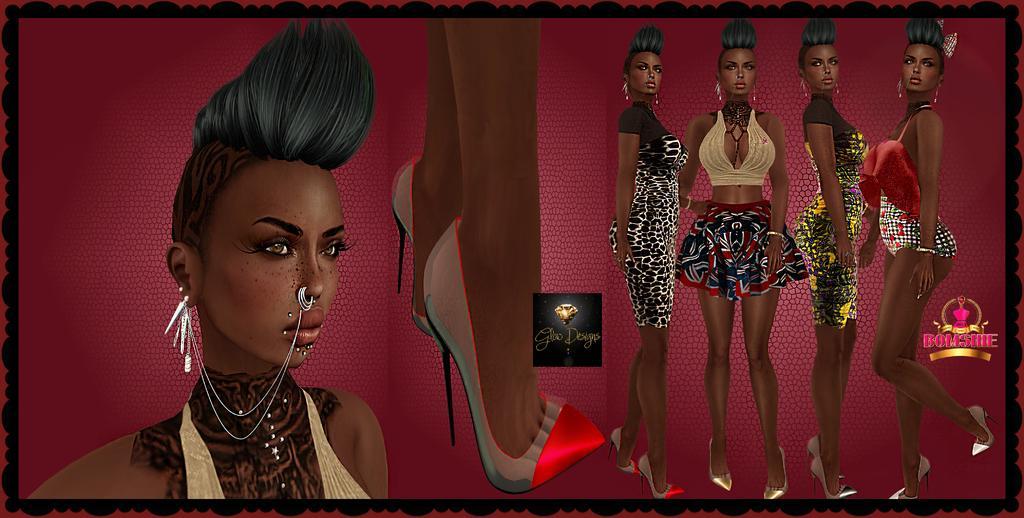How would you summarize this image in a sentence or two? This is an animated picture. In this picture we can see women standing. We can see text. In the middle portion of the picture we can see the legs of a person wearing sandals. 